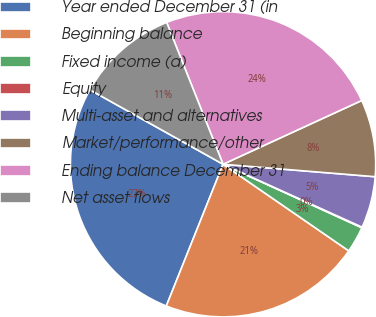Convert chart to OTSL. <chart><loc_0><loc_0><loc_500><loc_500><pie_chart><fcel>Year ended December 31 (in<fcel>Beginning balance<fcel>Fixed income (a)<fcel>Equity<fcel>Multi-asset and alternatives<fcel>Market/performance/other<fcel>Ending balance December 31<fcel>Net asset flows<nl><fcel>27.05%<fcel>21.46%<fcel>2.77%<fcel>0.07%<fcel>5.46%<fcel>8.16%<fcel>24.16%<fcel>10.86%<nl></chart> 